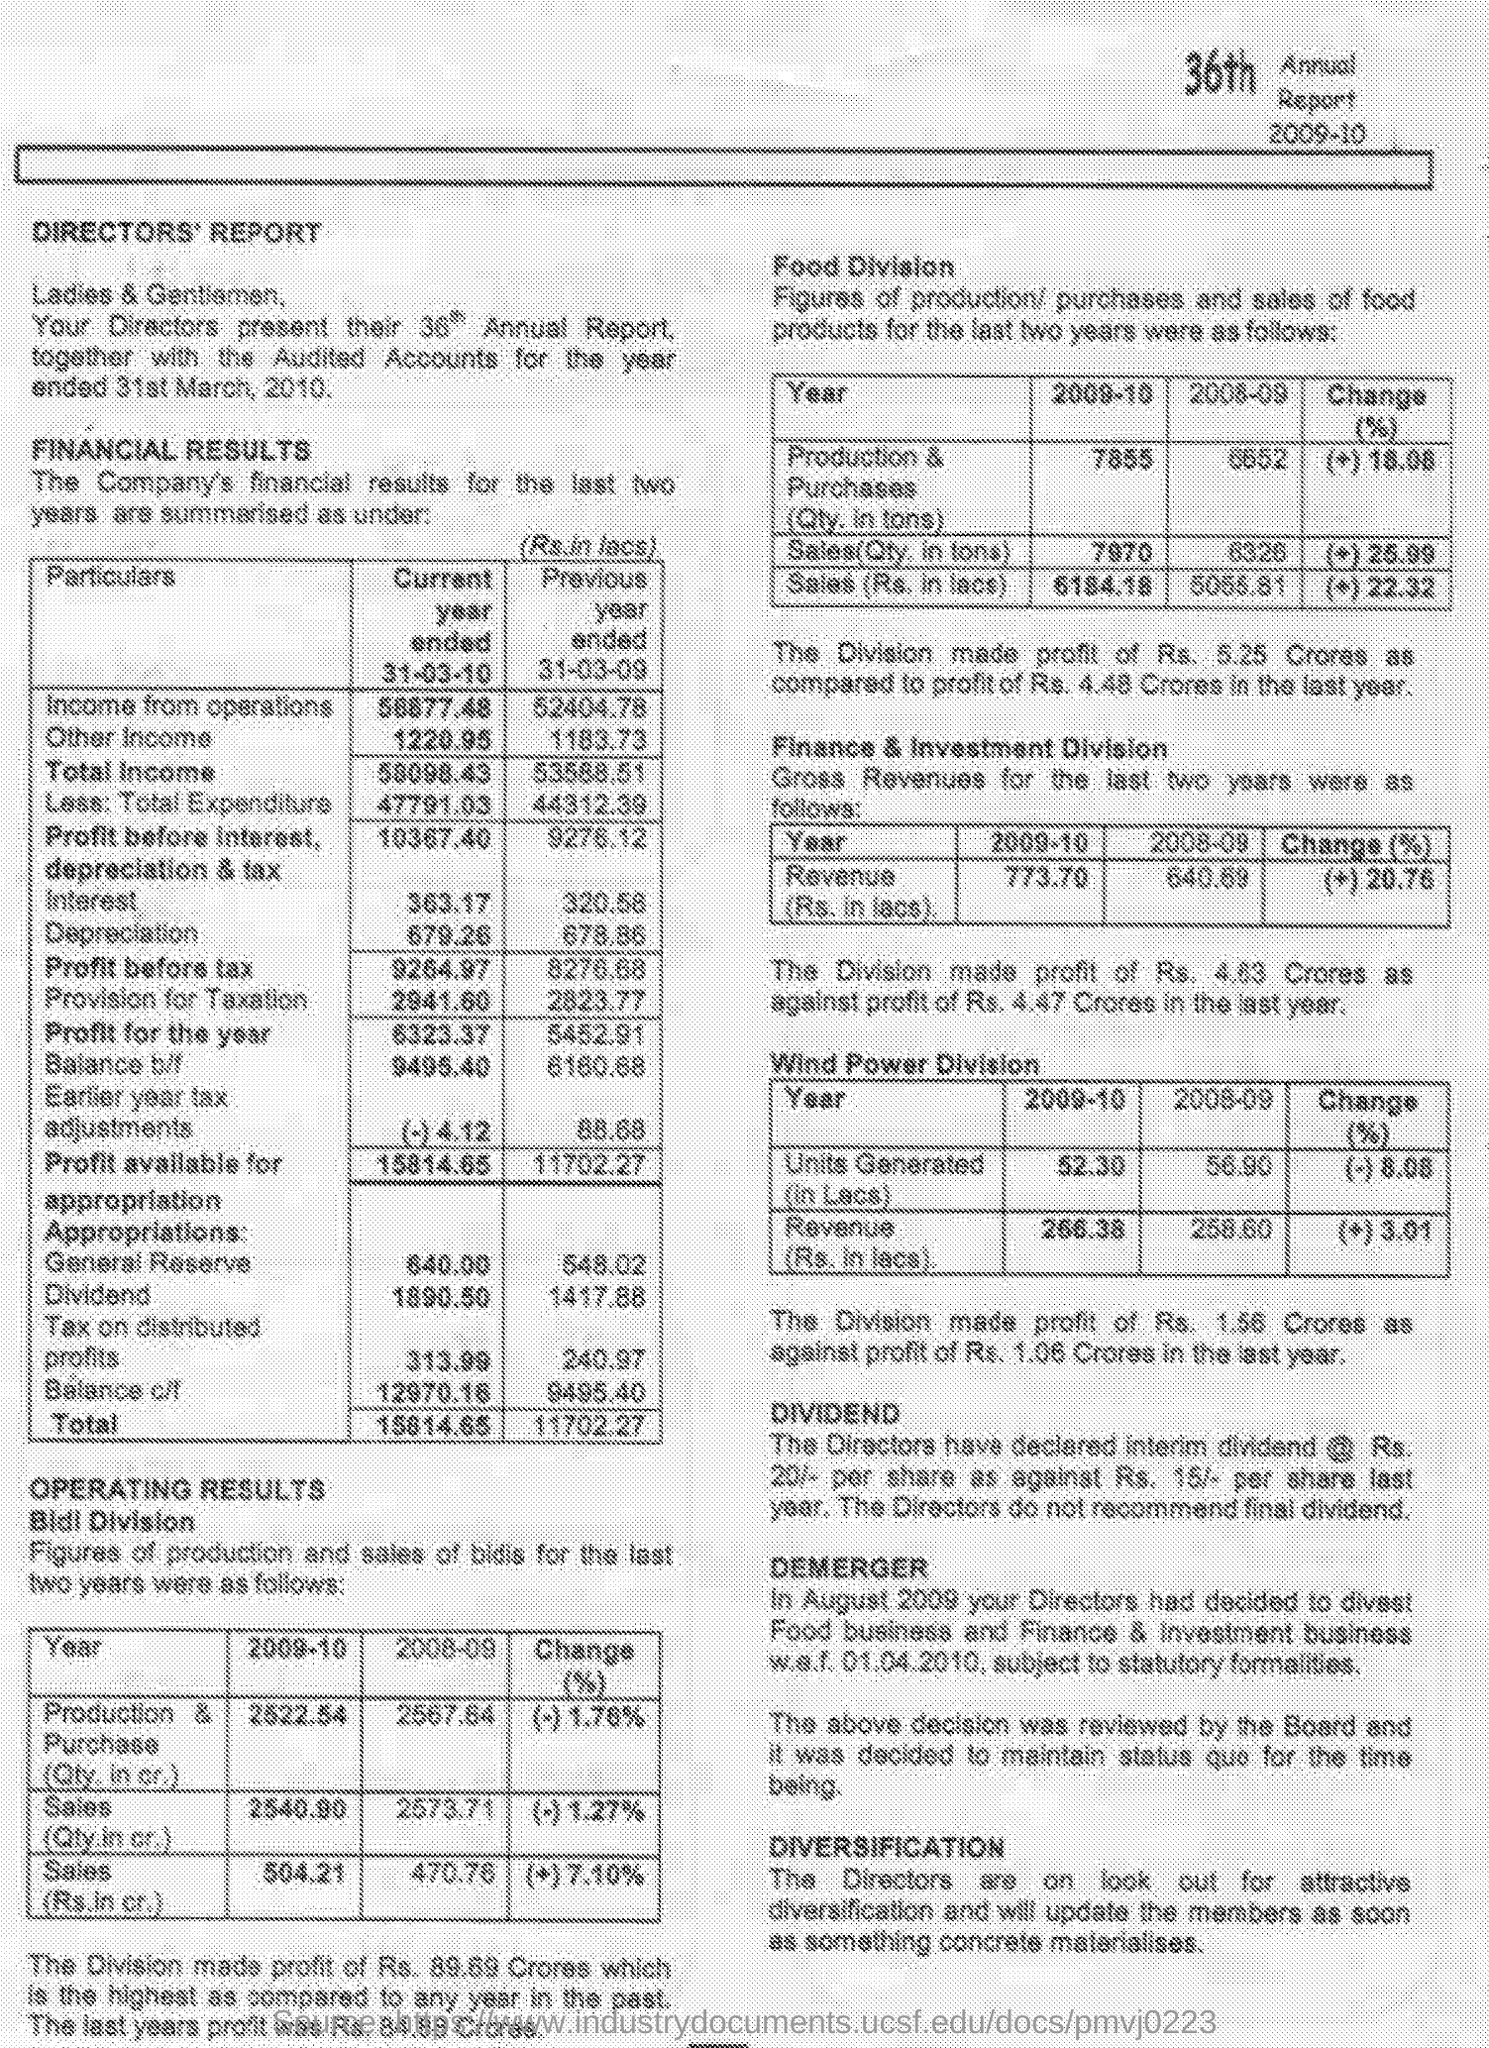Point out several critical features in this image. In 2008-09, the Sales (in lacs) for the Food Division was Rs. 5055.81. Income from operations for the previous year ended March 31, 2009, was 52,404.78. The profit of the "Finance & Investment Division" in the current year is Rs. 4.63 crores. In 2009-10, the Sales (Rs. in lacs) for the Food Division were 6184.18. The sales (in crores) for the Bldl Division in 2009-10 were Rs. 504.21. 